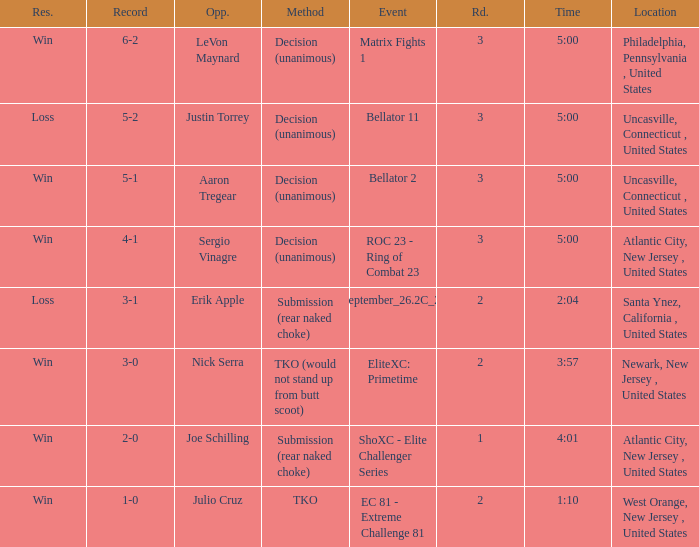I'm looking to parse the entire table for insights. Could you assist me with that? {'header': ['Res.', 'Record', 'Opp.', 'Method', 'Event', 'Rd.', 'Time', 'Location'], 'rows': [['Win', '6-2', 'LeVon Maynard', 'Decision (unanimous)', 'Matrix Fights 1', '3', '5:00', 'Philadelphia, Pennsylvania , United States'], ['Loss', '5-2', 'Justin Torrey', 'Decision (unanimous)', 'Bellator 11', '3', '5:00', 'Uncasville, Connecticut , United States'], ['Win', '5-1', 'Aaron Tregear', 'Decision (unanimous)', 'Bellator 2', '3', '5:00', 'Uncasville, Connecticut , United States'], ['Win', '4-1', 'Sergio Vinagre', 'Decision (unanimous)', 'ROC 23 - Ring of Combat 23', '3', '5:00', 'Atlantic City, New Jersey , United States'], ['Loss', '3-1', 'Erik Apple', 'Submission (rear naked choke)', 'ShoXC#September_26.2C_2008_card', '2', '2:04', 'Santa Ynez, California , United States'], ['Win', '3-0', 'Nick Serra', 'TKO (would not stand up from butt scoot)', 'EliteXC: Primetime', '2', '3:57', 'Newark, New Jersey , United States'], ['Win', '2-0', 'Joe Schilling', 'Submission (rear naked choke)', 'ShoXC - Elite Challenger Series', '1', '4:01', 'Atlantic City, New Jersey , United States'], ['Win', '1-0', 'Julio Cruz', 'TKO', 'EC 81 - Extreme Challenge 81', '2', '1:10', 'West Orange, New Jersey , United States']]} What was the round that Sergio Vinagre had a time of 5:00? 3.0. 